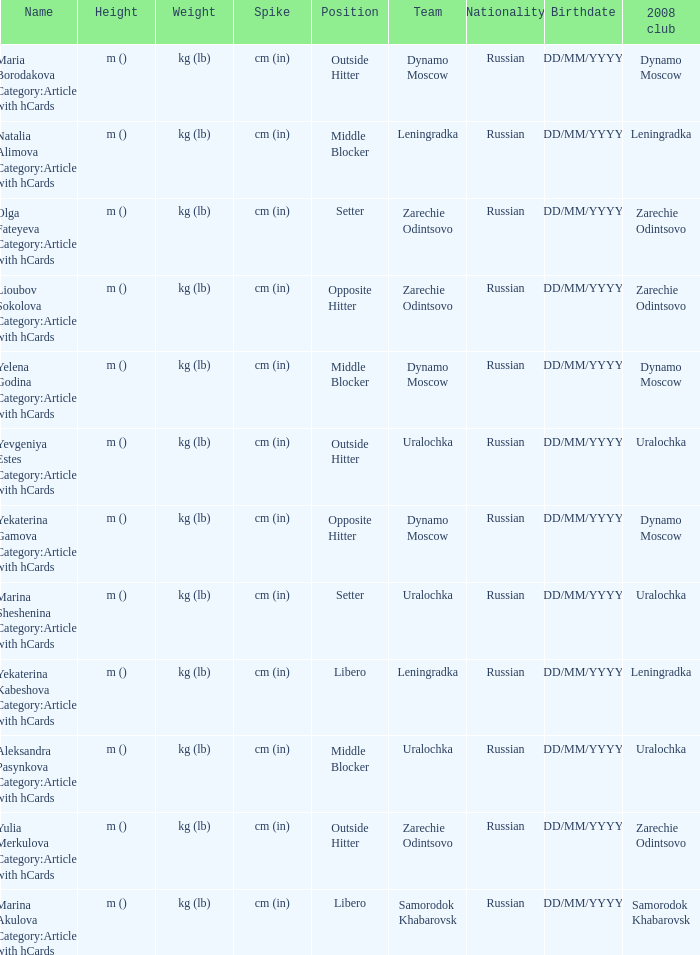What is the name when the 2008 club is uralochka? Yevgeniya Estes Category:Articles with hCards, Marina Sheshenina Category:Articles with hCards, Aleksandra Pasynkova Category:Articles with hCards. 